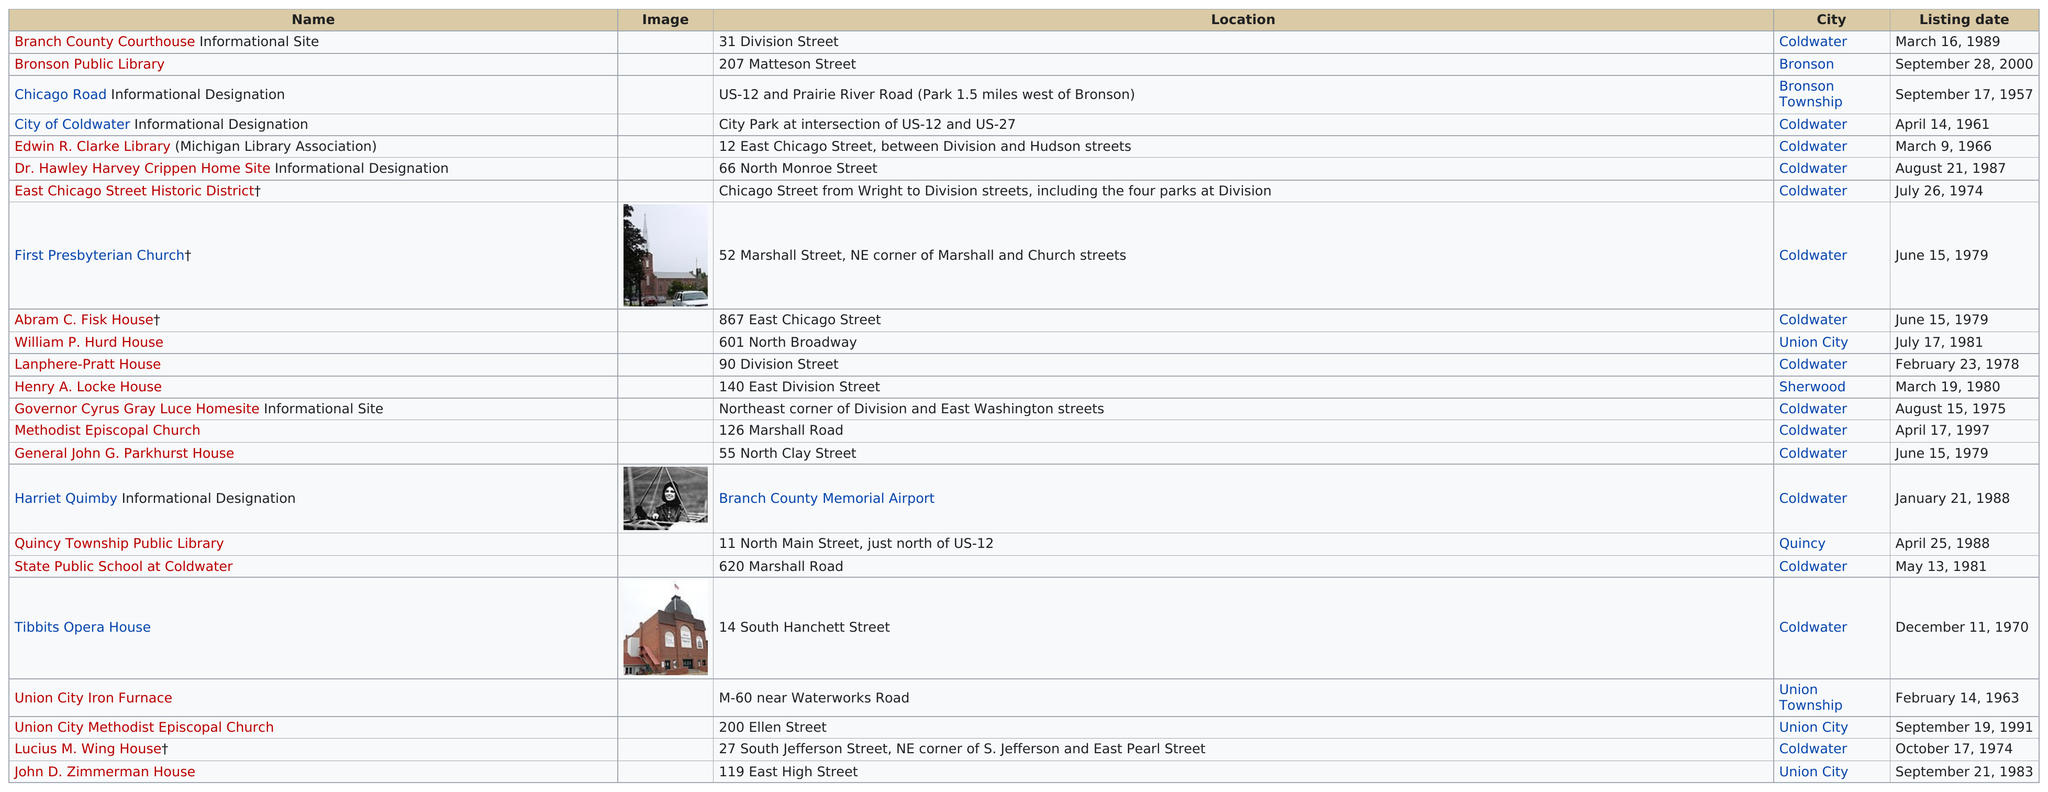Outline some significant characteristics in this image. Before 1965, there were a total of three historic sites that were listed. The Edwin R. Clarke Library was listed earlier than the state public school. There are 15 historic sites listed in Coldwater. There is no information provided about the amount of time that passed between the historic listing of public libraries in Quincy and Bronson. The following listing is located below Bronson Public Library, on Chicago Road. 